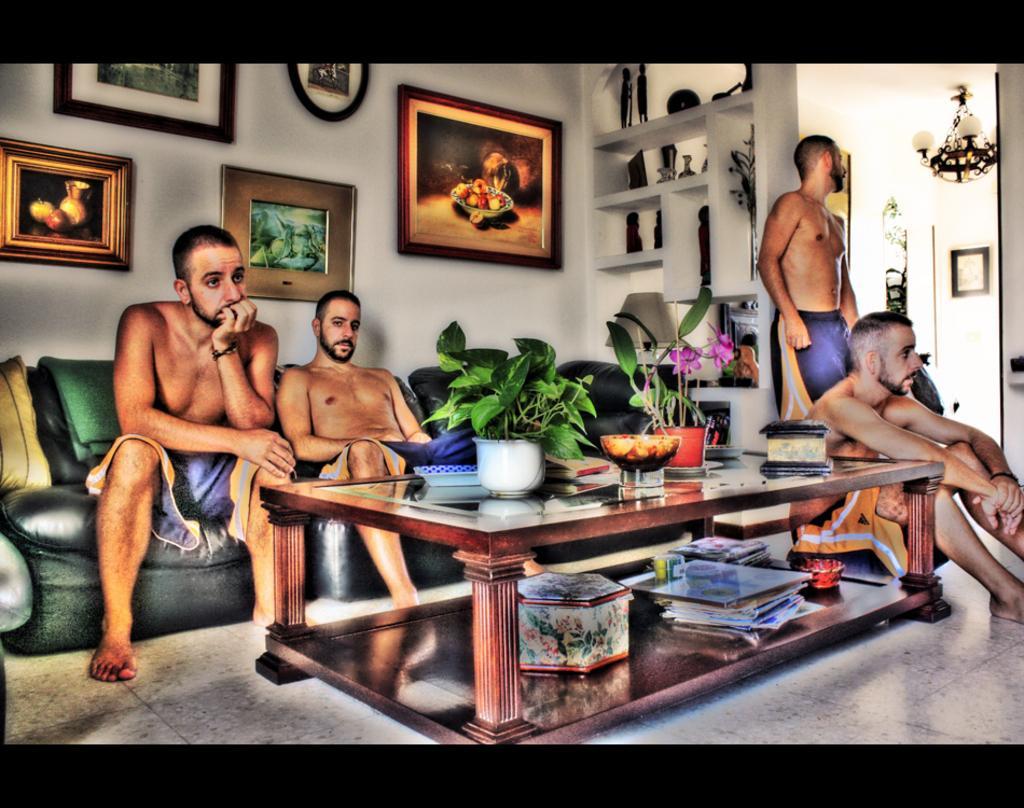Describe this image in one or two sentences. This is an edited image in which there is a table in the center and on the table there are plants, papers and boxes and there are persons sitting and standing and there are frames on the wall. In the background there is a chandelier hanging and there is a shelf and on the shelf there are objects which are black in colour. 